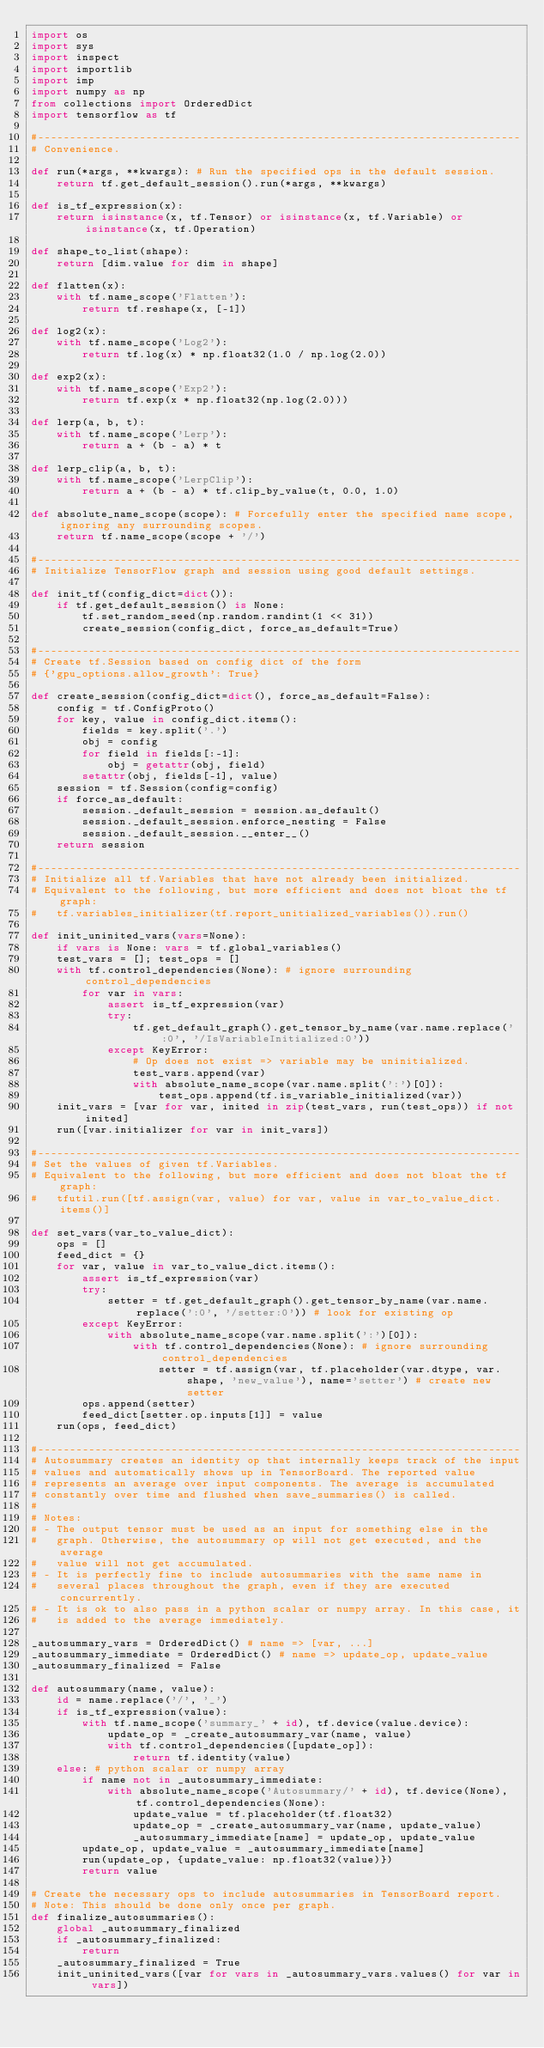Convert code to text. <code><loc_0><loc_0><loc_500><loc_500><_Python_>import os
import sys
import inspect
import importlib
import imp
import numpy as np
from collections import OrderedDict
import tensorflow as tf

#----------------------------------------------------------------------------
# Convenience.

def run(*args, **kwargs): # Run the specified ops in the default session.
    return tf.get_default_session().run(*args, **kwargs)

def is_tf_expression(x):
    return isinstance(x, tf.Tensor) or isinstance(x, tf.Variable) or isinstance(x, tf.Operation)

def shape_to_list(shape):
    return [dim.value for dim in shape]

def flatten(x):
    with tf.name_scope('Flatten'):
        return tf.reshape(x, [-1])

def log2(x):
    with tf.name_scope('Log2'):
        return tf.log(x) * np.float32(1.0 / np.log(2.0))

def exp2(x):
    with tf.name_scope('Exp2'):
        return tf.exp(x * np.float32(np.log(2.0)))

def lerp(a, b, t):
    with tf.name_scope('Lerp'):
        return a + (b - a) * t

def lerp_clip(a, b, t):
    with tf.name_scope('LerpClip'):
        return a + (b - a) * tf.clip_by_value(t, 0.0, 1.0)

def absolute_name_scope(scope): # Forcefully enter the specified name scope, ignoring any surrounding scopes.
    return tf.name_scope(scope + '/')

#----------------------------------------------------------------------------
# Initialize TensorFlow graph and session using good default settings.

def init_tf(config_dict=dict()):
    if tf.get_default_session() is None:
        tf.set_random_seed(np.random.randint(1 << 31))
        create_session(config_dict, force_as_default=True)

#----------------------------------------------------------------------------
# Create tf.Session based on config dict of the form
# {'gpu_options.allow_growth': True}

def create_session(config_dict=dict(), force_as_default=False):
    config = tf.ConfigProto()
    for key, value in config_dict.items():
        fields = key.split('.')
        obj = config
        for field in fields[:-1]:
            obj = getattr(obj, field)
        setattr(obj, fields[-1], value)
    session = tf.Session(config=config)
    if force_as_default:
        session._default_session = session.as_default()
        session._default_session.enforce_nesting = False
        session._default_session.__enter__()
    return session

#----------------------------------------------------------------------------
# Initialize all tf.Variables that have not already been initialized.
# Equivalent to the following, but more efficient and does not bloat the tf graph:
#   tf.variables_initializer(tf.report_unitialized_variables()).run()

def init_uninited_vars(vars=None):
    if vars is None: vars = tf.global_variables()
    test_vars = []; test_ops = []
    with tf.control_dependencies(None): # ignore surrounding control_dependencies
        for var in vars:
            assert is_tf_expression(var)
            try:
                tf.get_default_graph().get_tensor_by_name(var.name.replace(':0', '/IsVariableInitialized:0'))
            except KeyError:
                # Op does not exist => variable may be uninitialized.
                test_vars.append(var)
                with absolute_name_scope(var.name.split(':')[0]):
                    test_ops.append(tf.is_variable_initialized(var))
    init_vars = [var for var, inited in zip(test_vars, run(test_ops)) if not inited]
    run([var.initializer for var in init_vars])

#----------------------------------------------------------------------------
# Set the values of given tf.Variables.
# Equivalent to the following, but more efficient and does not bloat the tf graph:
#   tfutil.run([tf.assign(var, value) for var, value in var_to_value_dict.items()]

def set_vars(var_to_value_dict):
    ops = []
    feed_dict = {}
    for var, value in var_to_value_dict.items():
        assert is_tf_expression(var)
        try:
            setter = tf.get_default_graph().get_tensor_by_name(var.name.replace(':0', '/setter:0')) # look for existing op
        except KeyError:
            with absolute_name_scope(var.name.split(':')[0]):
                with tf.control_dependencies(None): # ignore surrounding control_dependencies
                    setter = tf.assign(var, tf.placeholder(var.dtype, var.shape, 'new_value'), name='setter') # create new setter
        ops.append(setter)
        feed_dict[setter.op.inputs[1]] = value
    run(ops, feed_dict)

#----------------------------------------------------------------------------
# Autosummary creates an identity op that internally keeps track of the input
# values and automatically shows up in TensorBoard. The reported value
# represents an average over input components. The average is accumulated
# constantly over time and flushed when save_summaries() is called.
#
# Notes:
# - The output tensor must be used as an input for something else in the
#   graph. Otherwise, the autosummary op will not get executed, and the average
#   value will not get accumulated.
# - It is perfectly fine to include autosummaries with the same name in
#   several places throughout the graph, even if they are executed concurrently.
# - It is ok to also pass in a python scalar or numpy array. In this case, it
#   is added to the average immediately.

_autosummary_vars = OrderedDict() # name => [var, ...]
_autosummary_immediate = OrderedDict() # name => update_op, update_value
_autosummary_finalized = False

def autosummary(name, value):
    id = name.replace('/', '_')
    if is_tf_expression(value):
        with tf.name_scope('summary_' + id), tf.device(value.device):
            update_op = _create_autosummary_var(name, value)
            with tf.control_dependencies([update_op]):
                return tf.identity(value)
    else: # python scalar or numpy array
        if name not in _autosummary_immediate:
            with absolute_name_scope('Autosummary/' + id), tf.device(None), tf.control_dependencies(None):
                update_value = tf.placeholder(tf.float32)
                update_op = _create_autosummary_var(name, update_value)
                _autosummary_immediate[name] = update_op, update_value
        update_op, update_value = _autosummary_immediate[name]
        run(update_op, {update_value: np.float32(value)})
        return value

# Create the necessary ops to include autosummaries in TensorBoard report.
# Note: This should be done only once per graph.
def finalize_autosummaries():
    global _autosummary_finalized
    if _autosummary_finalized:
        return
    _autosummary_finalized = True
    init_uninited_vars([var for vars in _autosummary_vars.values() for var in vars])</code> 